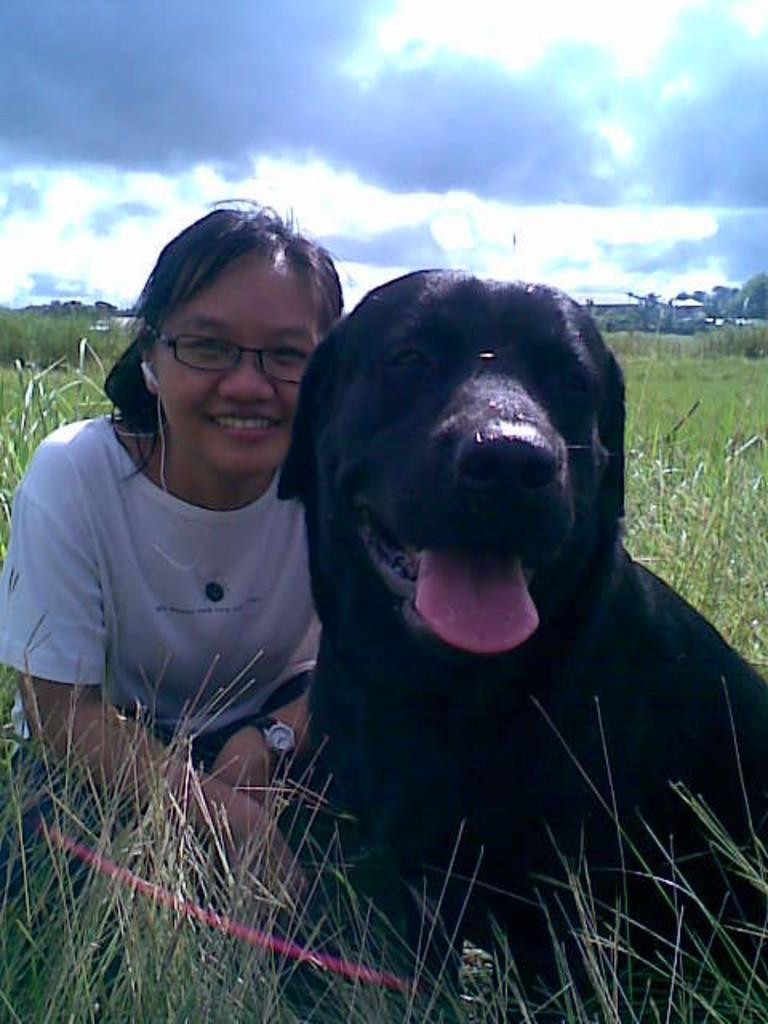Who or what can be seen in the image? There is a woman and a dog in the image. What are the woman and the dog doing in the image? Both the woman and the dog are sitting in the grass. What can be seen in the background of the image? The sky is cloudy in the background of the image. How many goldfish are swimming in the grass in the image? There are no goldfish present in the image; it features a woman and a dog sitting in the grass. What is the value of the elbow in the image? There is no mention of an elbow or any value associated with it in the image. 